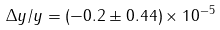Convert formula to latex. <formula><loc_0><loc_0><loc_500><loc_500>\Delta y / y = ( - 0 . 2 \pm 0 . 4 4 ) \times 1 0 ^ { - 5 }</formula> 